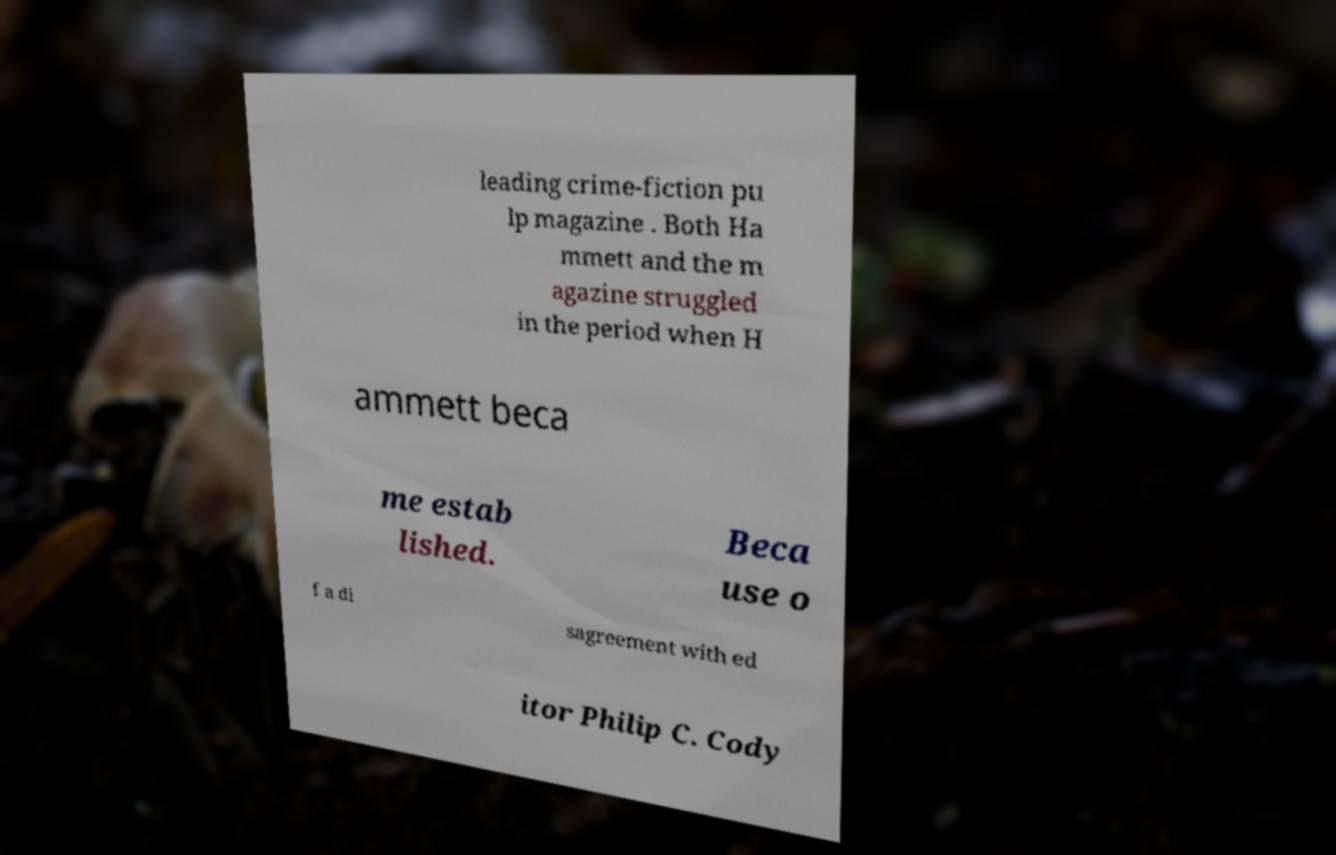Please read and relay the text visible in this image. What does it say? leading crime-fiction pu lp magazine . Both Ha mmett and the m agazine struggled in the period when H ammett beca me estab lished. Beca use o f a di sagreement with ed itor Philip C. Cody 